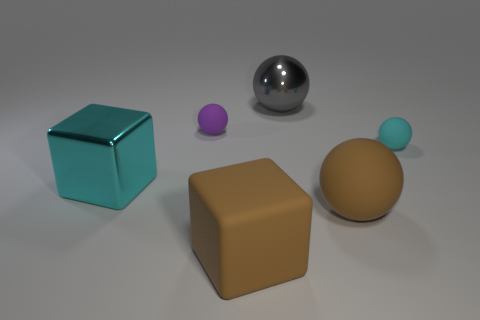There is a small cyan thing that is the same shape as the gray metallic thing; what material is it?
Provide a succinct answer. Rubber. Does the cyan object to the right of the large cyan object have the same size as the purple thing behind the large metal block?
Provide a succinct answer. Yes. How many other objects are there of the same size as the cyan rubber thing?
Offer a very short reply. 1. What is the material of the tiny sphere that is to the right of the shiny thing to the right of the cyan thing that is left of the large gray thing?
Your answer should be compact. Rubber. Does the gray shiny sphere have the same size as the cyan object that is behind the shiny cube?
Your answer should be very brief. No. How big is the rubber sphere that is left of the small cyan sphere and to the right of the purple matte thing?
Offer a very short reply. Large. Are there any objects of the same color as the big rubber block?
Provide a short and direct response. Yes. What is the color of the big cube that is to the right of the large metal object in front of the purple sphere?
Provide a short and direct response. Brown. Is the number of brown matte blocks that are on the left side of the small purple rubber sphere less than the number of matte spheres on the left side of the cyan ball?
Your response must be concise. Yes. Do the purple sphere and the gray ball have the same size?
Offer a very short reply. No. 